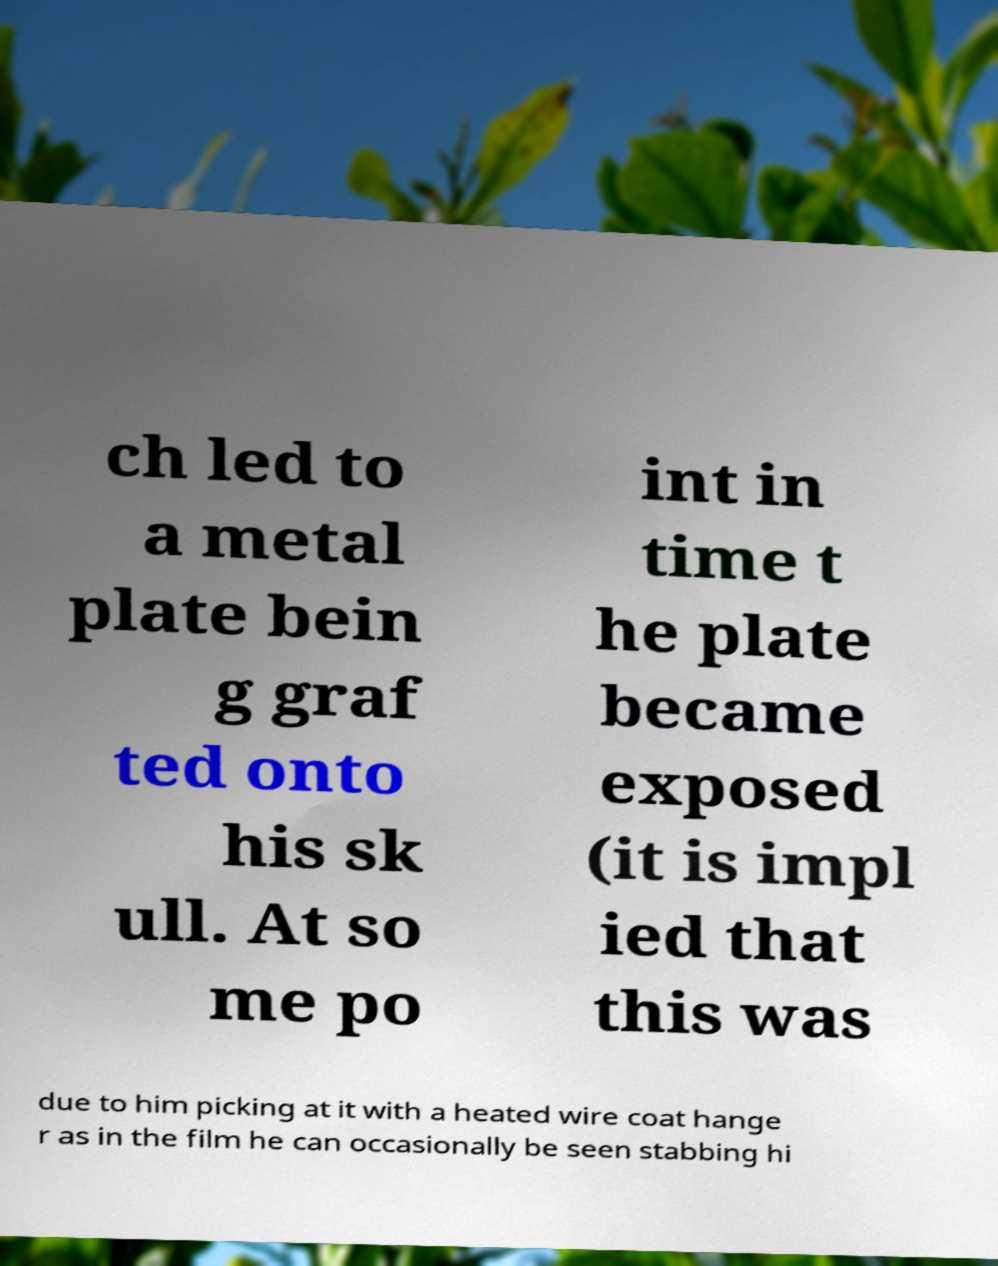Could you assist in decoding the text presented in this image and type it out clearly? ch led to a metal plate bein g graf ted onto his sk ull. At so me po int in time t he plate became exposed (it is impl ied that this was due to him picking at it with a heated wire coat hange r as in the film he can occasionally be seen stabbing hi 